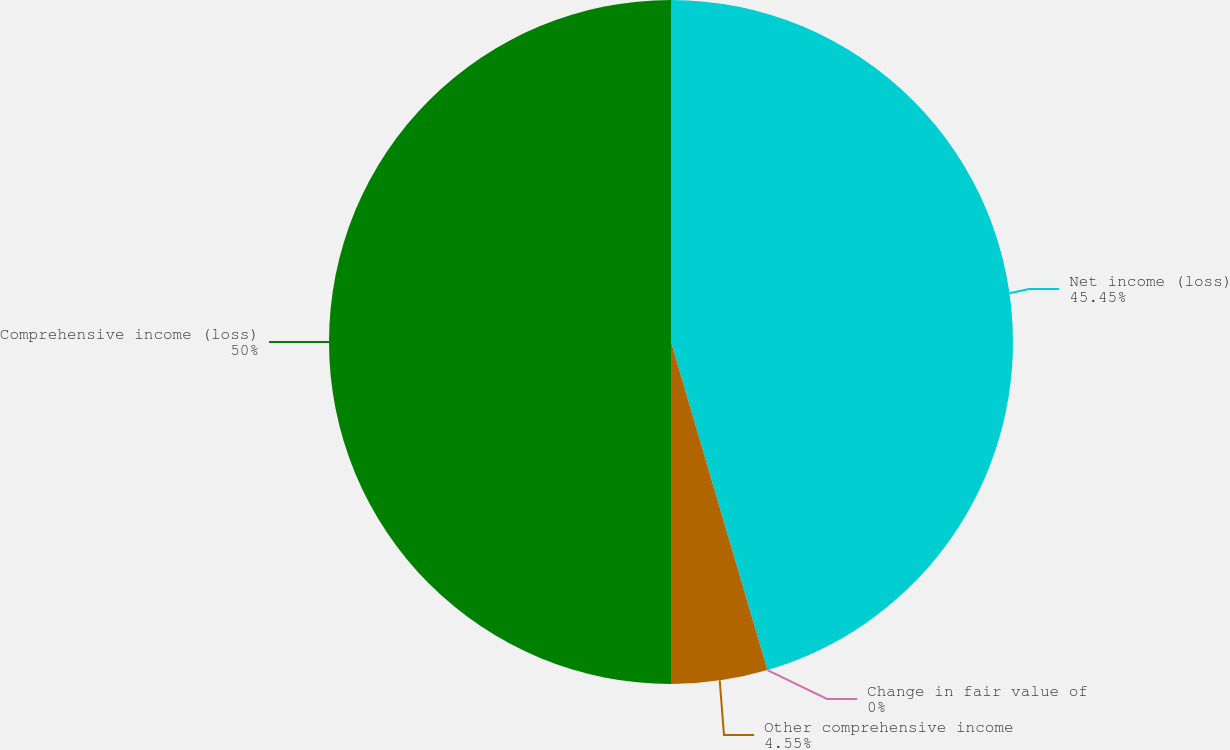Convert chart to OTSL. <chart><loc_0><loc_0><loc_500><loc_500><pie_chart><fcel>Net income (loss)<fcel>Change in fair value of<fcel>Other comprehensive income<fcel>Comprehensive income (loss)<nl><fcel>45.45%<fcel>0.0%<fcel>4.55%<fcel>50.0%<nl></chart> 